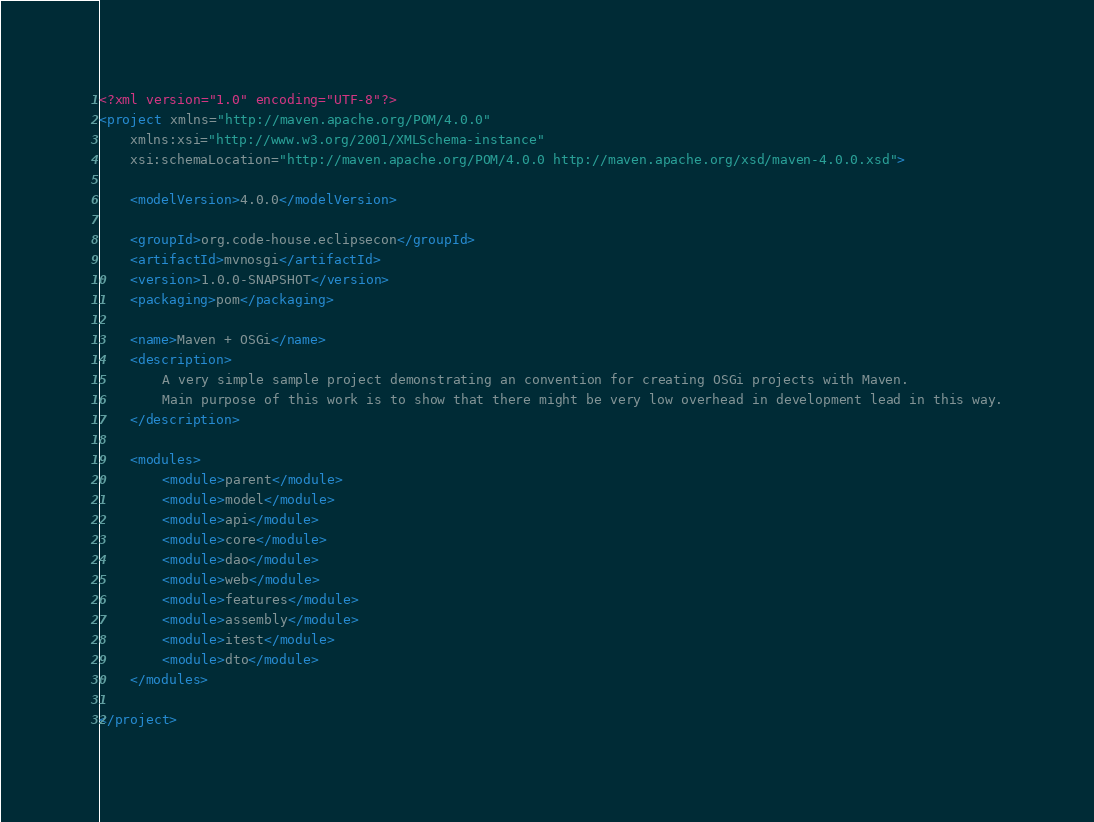<code> <loc_0><loc_0><loc_500><loc_500><_XML_><?xml version="1.0" encoding="UTF-8"?>
<project xmlns="http://maven.apache.org/POM/4.0.0"
    xmlns:xsi="http://www.w3.org/2001/XMLSchema-instance"
    xsi:schemaLocation="http://maven.apache.org/POM/4.0.0 http://maven.apache.org/xsd/maven-4.0.0.xsd">

    <modelVersion>4.0.0</modelVersion>

    <groupId>org.code-house.eclipsecon</groupId>
    <artifactId>mvnosgi</artifactId>
    <version>1.0.0-SNAPSHOT</version>
    <packaging>pom</packaging>

    <name>Maven + OSGi</name>
    <description>
        A very simple sample project demonstrating an convention for creating OSGi projects with Maven.
        Main purpose of this work is to show that there might be very low overhead in development lead in this way.
    </description>

    <modules>
        <module>parent</module>
        <module>model</module>
        <module>api</module>
        <module>core</module>
        <module>dao</module>
        <module>web</module>
        <module>features</module>
        <module>assembly</module>
        <module>itest</module>
        <module>dto</module>
    </modules>

</project></code> 